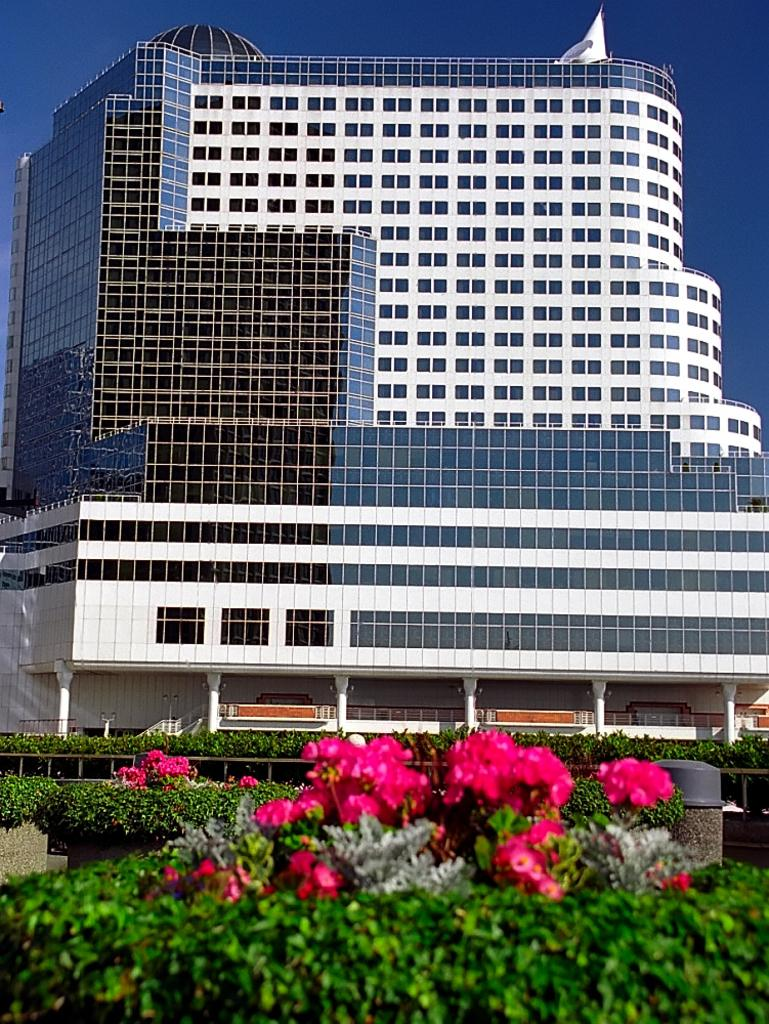What type of building is visible in the image? There is a glass building in the image. What can be seen surrounding the building? There is fencing in the image. What type of vegetation is present in the image? There are plants in the image, including pink color flowers. What color is the sky in the image? The sky is blue in the image. What type of bells can be heard ringing in the image? There are no bells present in the image, and therefore no sound can be heard. 